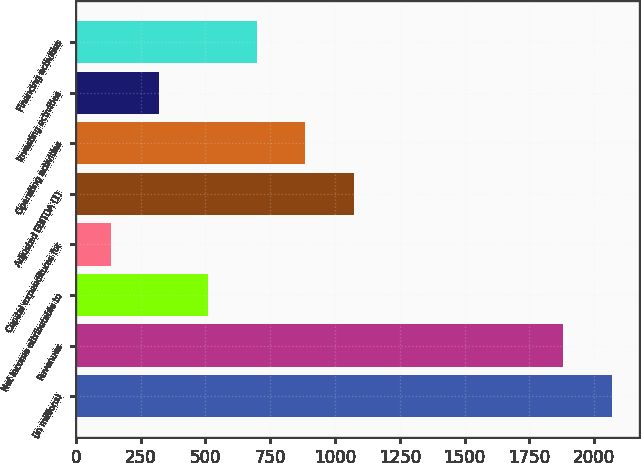Convert chart. <chart><loc_0><loc_0><loc_500><loc_500><bar_chart><fcel>(in millions)<fcel>Revenues<fcel>Net income attributable to<fcel>Capital expenditures for<fcel>Adjusted EBITDA (1)<fcel>Operating activities<fcel>Investing activities<fcel>Financing activities<nl><fcel>2067.9<fcel>1880<fcel>509.8<fcel>134<fcel>1073.5<fcel>885.6<fcel>321.9<fcel>697.7<nl></chart> 